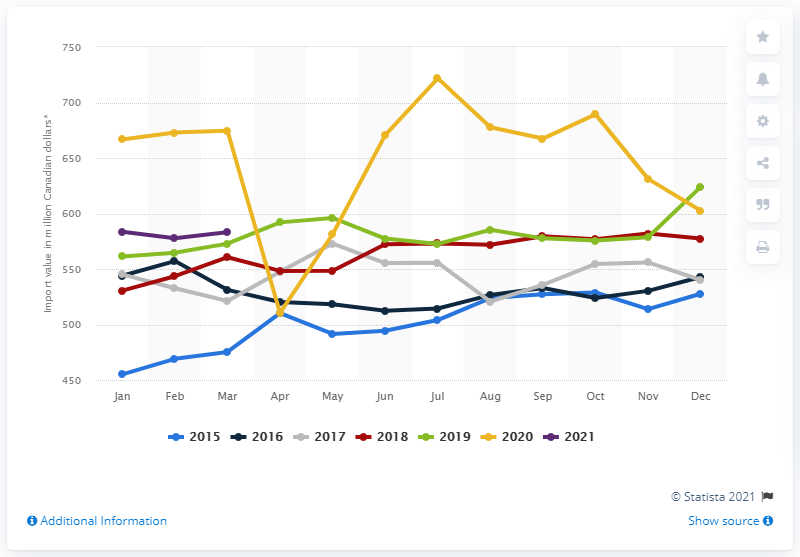Outline some significant characteristics in this image. In March 2021, the value of cleaning products and toiletries imported in Canada was CAD 577.4 million. 